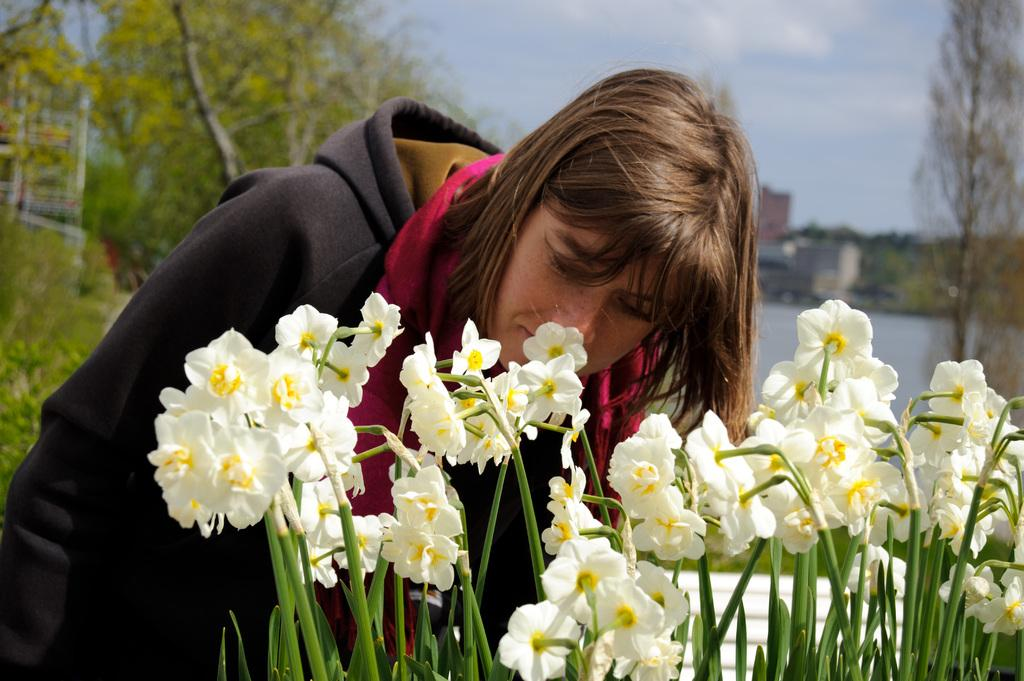Who is present in the image? There is a lady in the image. What type of flora can be seen in the image? There are flowers, plants, and trees in the image. What type of structures are visible in the image? There are buildings in the image. What part of the natural environment is visible in the image? The sky is visible in the image. Can you see a train passing by in the image? There is no train present in the image. Is the lady kicking a loaf of bread in the image? There is no loaf of bread or indication of kicking in the image. 